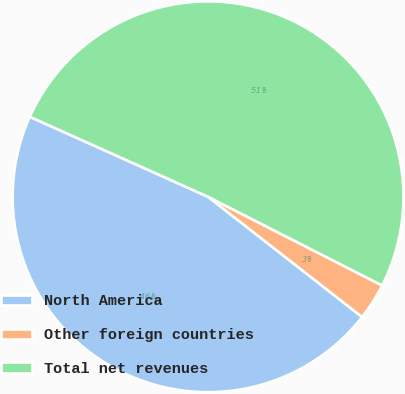Convert chart to OTSL. <chart><loc_0><loc_0><loc_500><loc_500><pie_chart><fcel>North America<fcel>Other foreign countries<fcel>Total net revenues<nl><fcel>46.17%<fcel>3.05%<fcel>50.78%<nl></chart> 